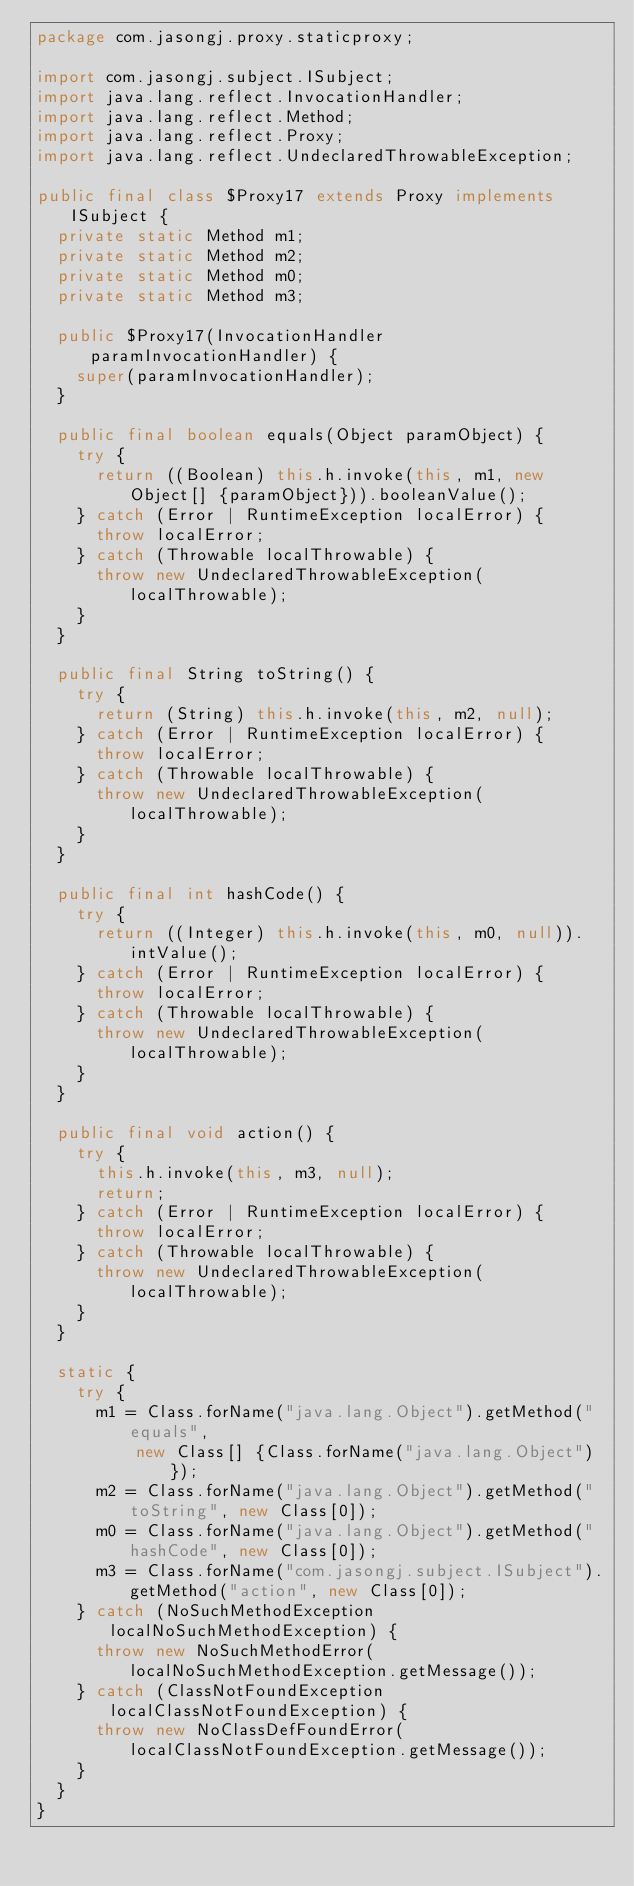Convert code to text. <code><loc_0><loc_0><loc_500><loc_500><_Java_>package com.jasongj.proxy.staticproxy;

import com.jasongj.subject.ISubject;
import java.lang.reflect.InvocationHandler;
import java.lang.reflect.Method;
import java.lang.reflect.Proxy;
import java.lang.reflect.UndeclaredThrowableException;

public final class $Proxy17 extends Proxy implements ISubject {
  private static Method m1;
  private static Method m2;
  private static Method m0;
  private static Method m3;

  public $Proxy17(InvocationHandler paramInvocationHandler) {
    super(paramInvocationHandler);
  }

  public final boolean equals(Object paramObject) {
    try {
      return ((Boolean) this.h.invoke(this, m1, new Object[] {paramObject})).booleanValue();
    } catch (Error | RuntimeException localError) {
      throw localError;
    } catch (Throwable localThrowable) {
      throw new UndeclaredThrowableException(localThrowable);
    }
  }

  public final String toString() {
    try {
      return (String) this.h.invoke(this, m2, null);
    } catch (Error | RuntimeException localError) {
      throw localError;
    } catch (Throwable localThrowable) {
      throw new UndeclaredThrowableException(localThrowable);
    }
  }

  public final int hashCode() {
    try {
      return ((Integer) this.h.invoke(this, m0, null)).intValue();
    } catch (Error | RuntimeException localError) {
      throw localError;
    } catch (Throwable localThrowable) {
      throw new UndeclaredThrowableException(localThrowable);
    }
  }

  public final void action() {
    try {
      this.h.invoke(this, m3, null);
      return;
    } catch (Error | RuntimeException localError) {
      throw localError;
    } catch (Throwable localThrowable) {
      throw new UndeclaredThrowableException(localThrowable);
    }
  }

  static {
    try {
      m1 = Class.forName("java.lang.Object").getMethod("equals",
          new Class[] {Class.forName("java.lang.Object")});
      m2 = Class.forName("java.lang.Object").getMethod("toString", new Class[0]);
      m0 = Class.forName("java.lang.Object").getMethod("hashCode", new Class[0]);
      m3 = Class.forName("com.jasongj.subject.ISubject").getMethod("action", new Class[0]);
    } catch (NoSuchMethodException localNoSuchMethodException) {
      throw new NoSuchMethodError(localNoSuchMethodException.getMessage());
    } catch (ClassNotFoundException localClassNotFoundException) {
      throw new NoClassDefFoundError(localClassNotFoundException.getMessage());
    }
  }
}
</code> 